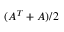Convert formula to latex. <formula><loc_0><loc_0><loc_500><loc_500>( A ^ { T } + A ) / 2</formula> 